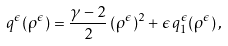Convert formula to latex. <formula><loc_0><loc_0><loc_500><loc_500>q ^ { \epsilon } ( \rho ^ { \epsilon } ) = \frac { \gamma - 2 } { 2 } \, ( \rho ^ { \epsilon } ) ^ { 2 } + \epsilon \, q _ { 1 } ^ { \epsilon } ( \rho ^ { \epsilon } ) \, ,</formula> 